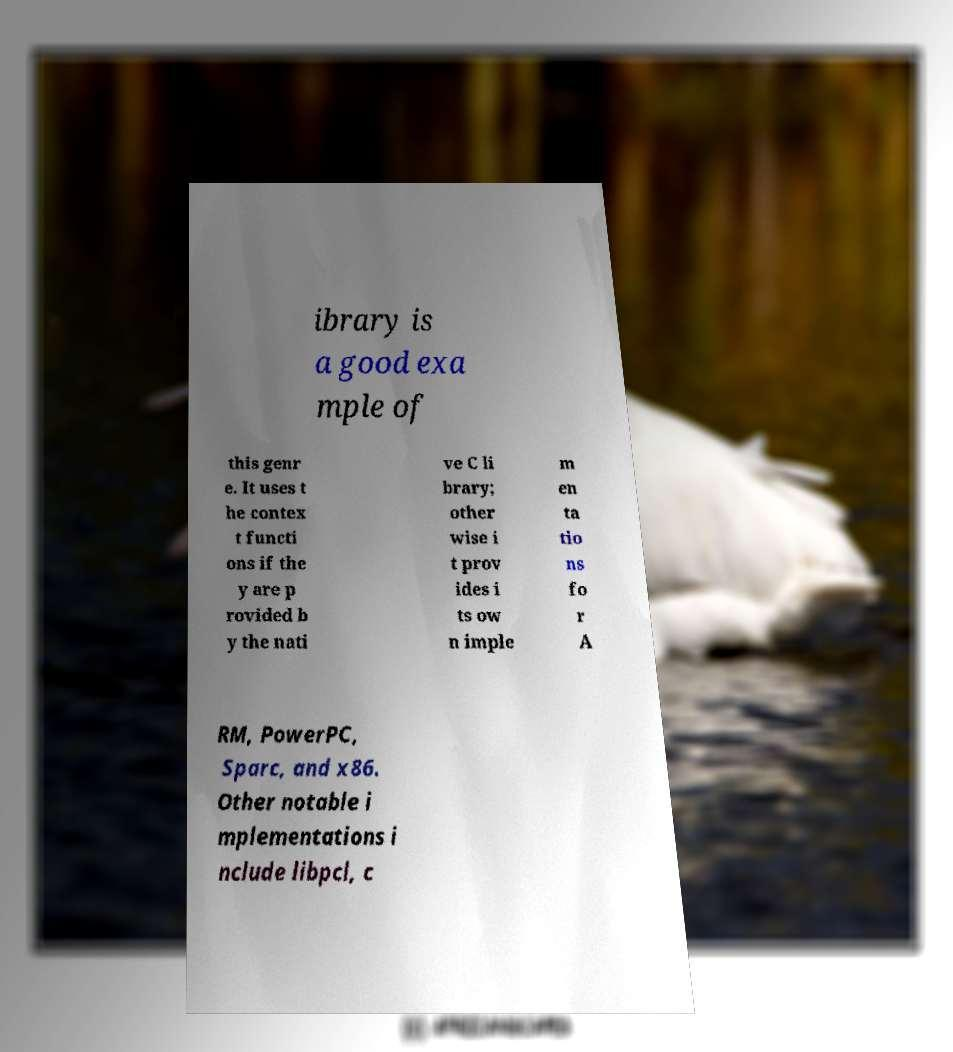There's text embedded in this image that I need extracted. Can you transcribe it verbatim? ibrary is a good exa mple of this genr e. It uses t he contex t functi ons if the y are p rovided b y the nati ve C li brary; other wise i t prov ides i ts ow n imple m en ta tio ns fo r A RM, PowerPC, Sparc, and x86. Other notable i mplementations i nclude libpcl, c 